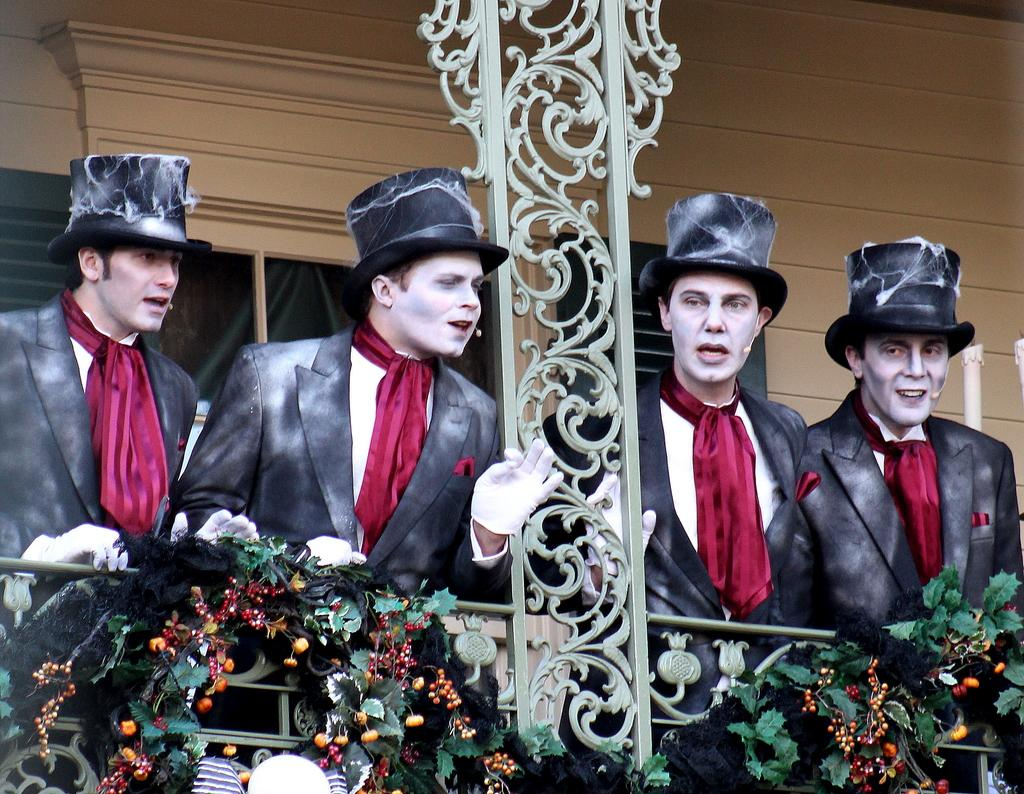What are the people in the image wearing on their heads? The people are wearing caps in the image. What other accessories can be seen on the people in the image? The people are also wearing gloves and mics in the image. What can be seen in the background of the image? There is a wall, railings, and Christmas ornaments in the background of the image. What type of plant is being used as a secretary in the image? There is no plant or secretary present in the image. What type of voyage are the people in the image embarking on? There is no indication of a voyage in the image; the people are wearing costumes and accessories. 